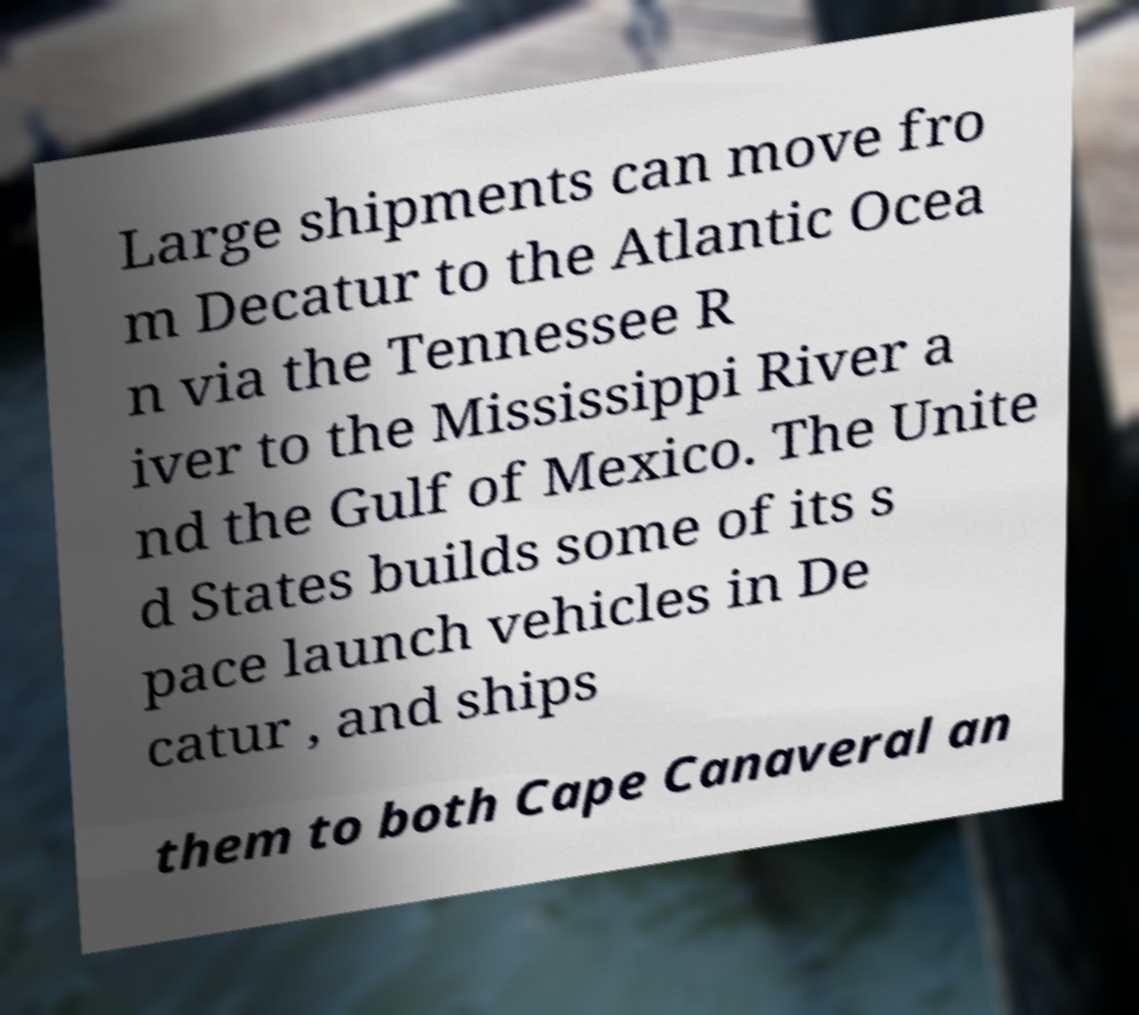Please read and relay the text visible in this image. What does it say? Large shipments can move fro m Decatur to the Atlantic Ocea n via the Tennessee R iver to the Mississippi River a nd the Gulf of Mexico. The Unite d States builds some of its s pace launch vehicles in De catur , and ships them to both Cape Canaveral an 